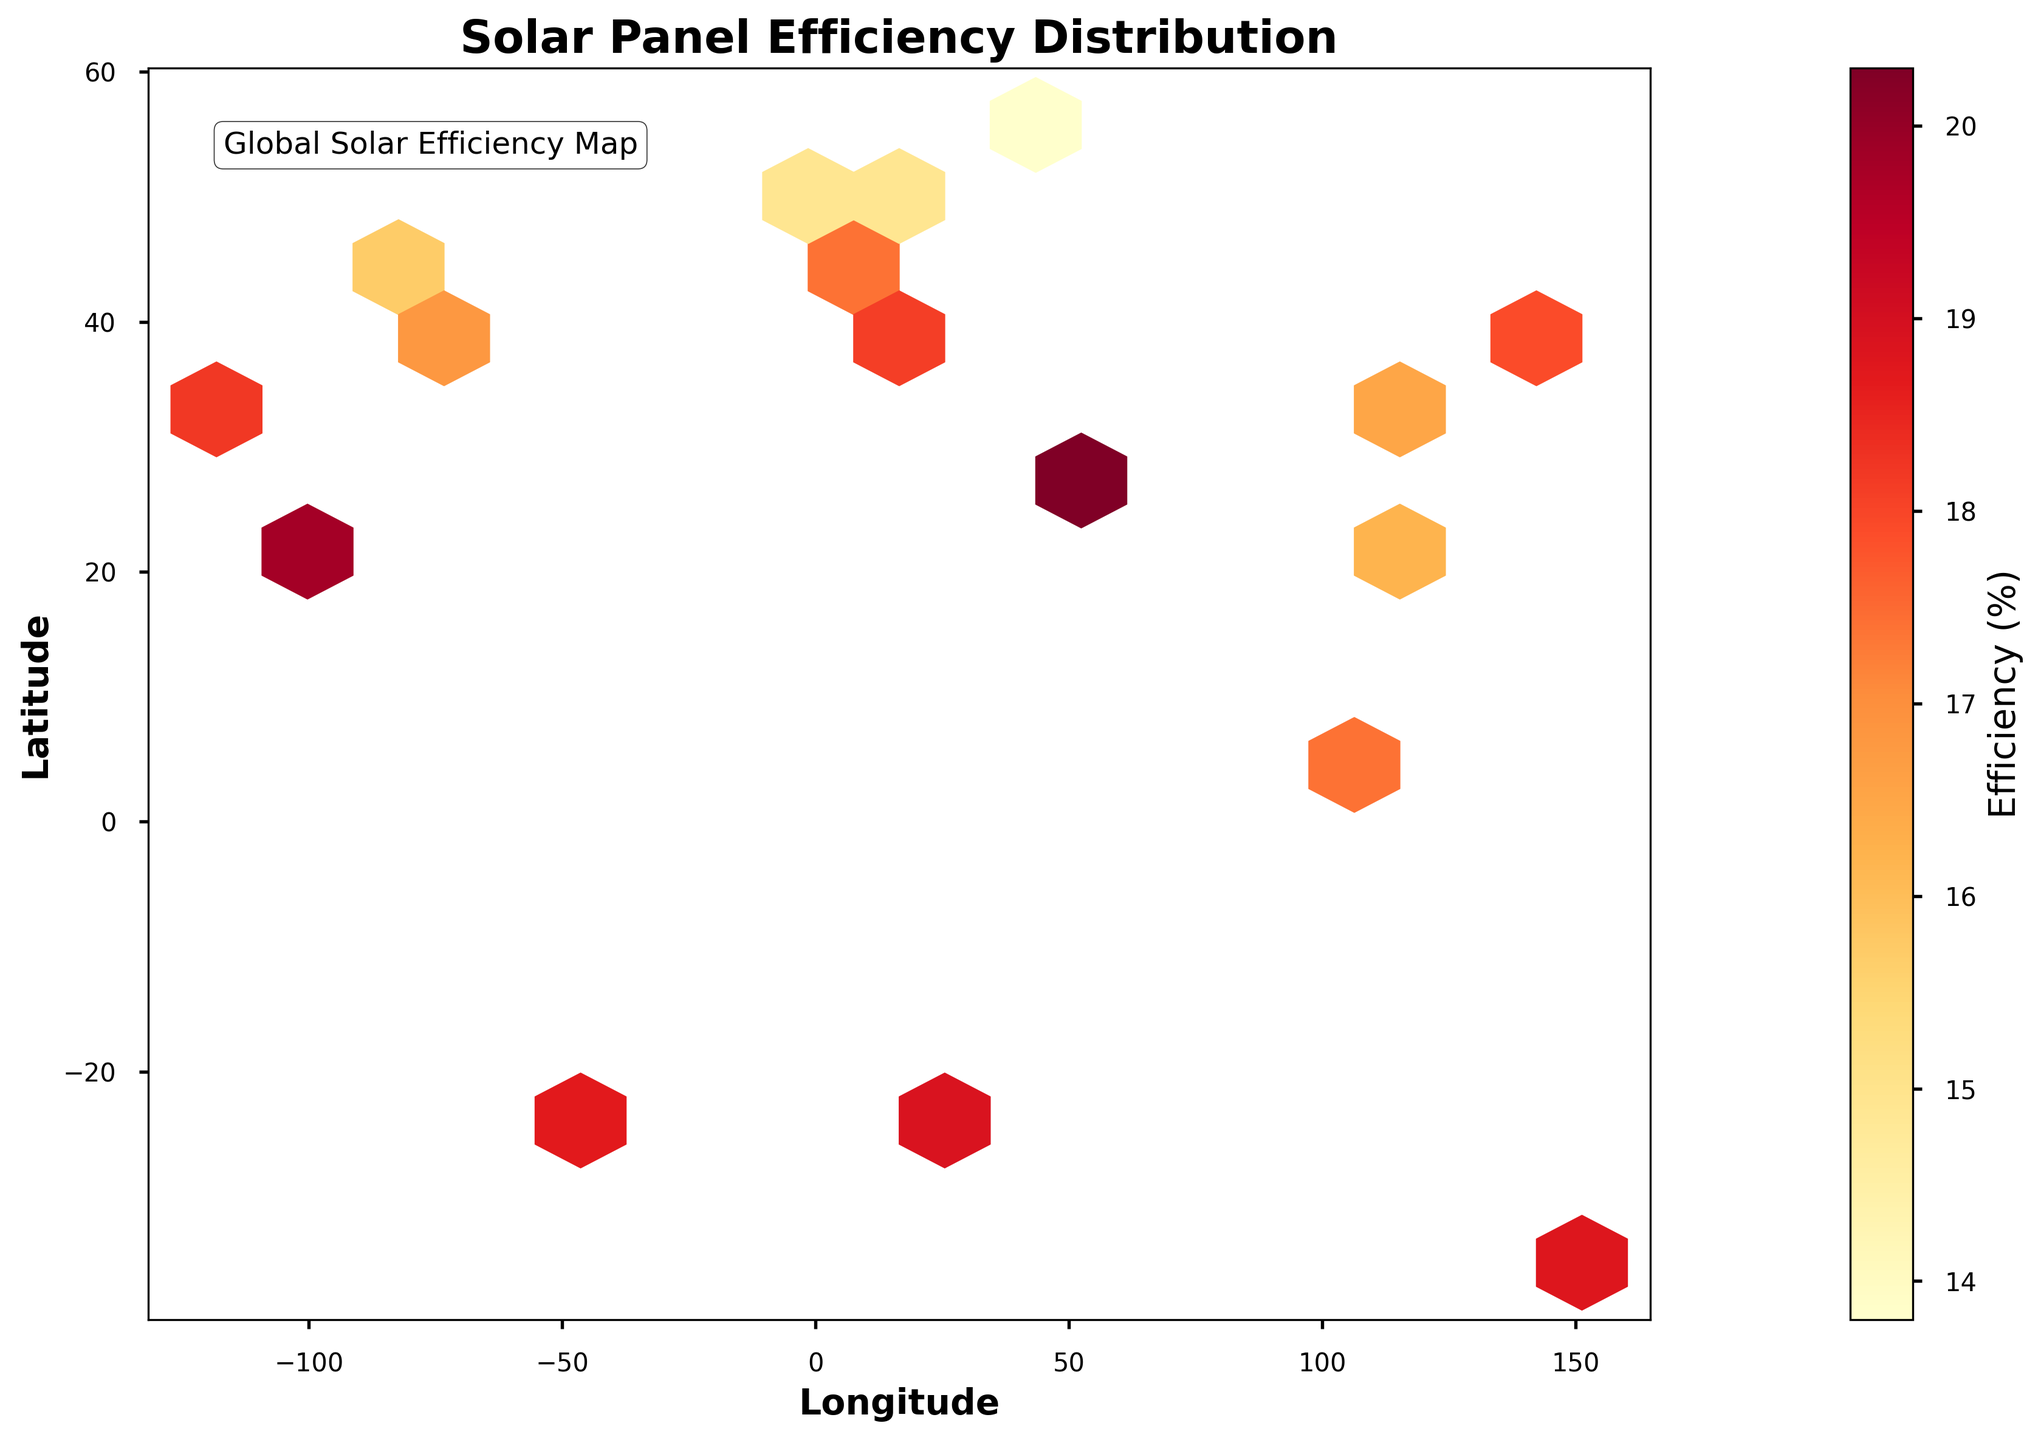What does the title of the plot indicate? The title 'Solar Panel Efficiency Distribution' suggests that the plot is showing how solar panel efficiency is distributed across various geographical locations. Based on this title, we can infer the focus of the visualization is on the efficiency rates of solar panels in different places.
Answer: Solar Panel Efficiency Distribution What do the axes labels signify in the plot? The x-axis is labeled 'Longitude' and the y-axis is labeled 'Latitude.' These labels indicate that the plot maps solar panel efficiency across geographical coordinates. Specifically, longitude measures the position east or west of the Prime Meridian, and latitude measures the position north or south of the Equator.
Answer: Longitude and Latitude How is solar panel efficiency visually represented in the plot? Solar panel efficiency is represented by the color intensity in the hexagon bins. Warmer colors (closer to red) correspond to higher efficiencies, while cooler colors (closer to yellow) indicate lower efficiencies. This color gradient allows for an easy visual comparison of efficiencies across different geographical areas.
Answer: Color intensity in hexagons Which geographical location seems to have the highest solar panel efficiency? According to the figure, the location with the highest efficiency appears to be around the region of latitude 25.2048 and longitude 55.2708, which is Dubai. The higher concentration of darker (reddish) color in this location indicates higher solar panel efficiency.
Answer: Dubai Are there any noticeable clusters of high-efficiency solar panels? If so, where? Yes, there are clusters of high-efficiency solar panels noticeable in the plot. These clusters can be seen in regions such as Dubai (latitude 25.2048, longitude 55.2708) and Mexico City (latitude 19.4326, longitude -99.1332). These areas are marked by darker shades of red, suggesting higher efficiency.
Answer: Dubai and Mexico City Which longitude range appears to have a lower overall efficiency? The plot indicates that the longitude range around 37.6173 (Moscow) and 13.4050 (Berlin) has lower efficiencies. These regions are represented by lighter colors, showing that the solar panels are less efficient here compared to other locations.
Answer: Around Moscow and Berlin Is there any correlation visible between latitude and solar panel efficiency? The plot suggests a visual trend where locations closer to the equator (0º latitude) tend to have higher solar panel efficiency. This can be inferred from the darker (reddish) colored bins around lower latitudes and lighter colors as you move towards higher latitudes (away from the equator).
Answer: Higher efficiency closer to the equator How does the solar panel efficiency in Sydney compare to that in London? Sydney (latitude -33.8688, longitude 151.2093) displays a higher solar panel efficiency compared to London (latitude 51.5074, longitude -0.1278). This can be determined by the darker shade of red observed in Sydney's hexbin, indicating a higher efficiency rate.
Answer: Higher in Sydney What does the color gradient on the hexagons represent? The color gradient on the hexagons represents solar panel efficiency percentages. The gradient typically ranges from light yellow (lower efficiency) to dark red (higher efficiency), providing a visual cue for understanding the efficiency levels across various regions.
Answer: Solar panel efficiency percentages Which locations seem to have a mid-range solar panel efficiency? The locations with mid-range solar panel efficiency are noticeable in regions like Beijing (latitude 35.6762, longitude 139.6503) and Hong Kong (latitude 22.3193, longitude 114.1694). These areas are represented by medium shades, neither too light nor too dark, indicating mid-level efficiency.
Answer: Beijing and Hong Kong 